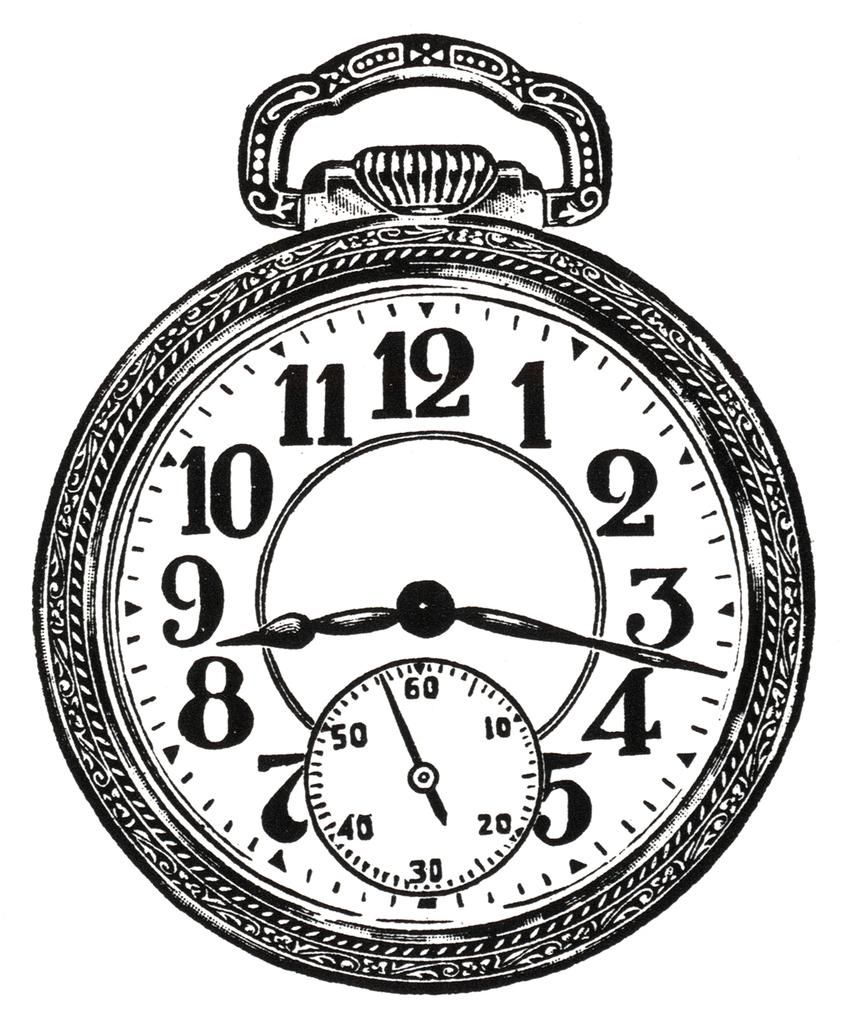<image>
Offer a succinct explanation of the picture presented. The time on the clock is 8:17 P.M. 